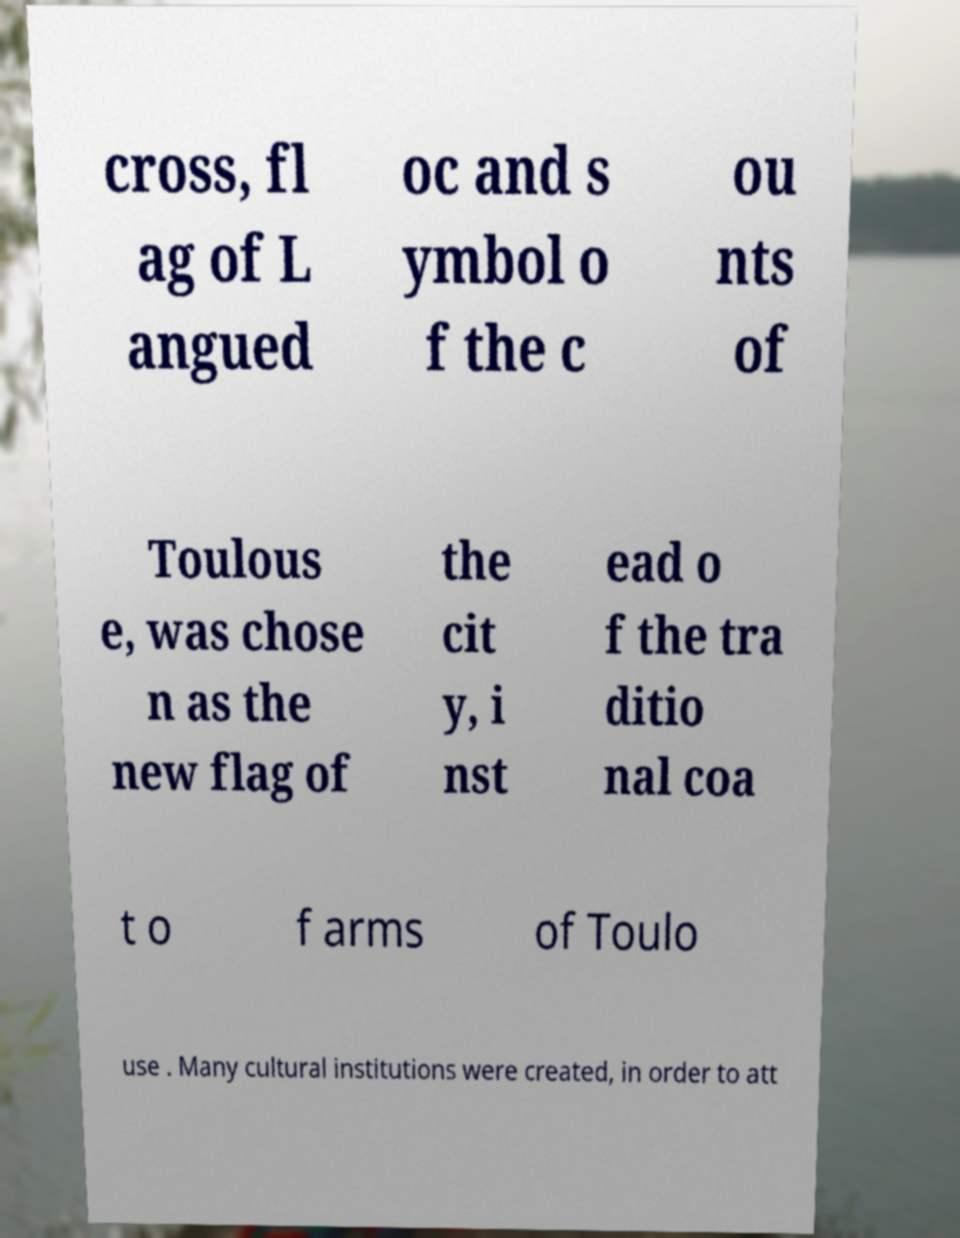What messages or text are displayed in this image? I need them in a readable, typed format. cross, fl ag of L angued oc and s ymbol o f the c ou nts of Toulous e, was chose n as the new flag of the cit y, i nst ead o f the tra ditio nal coa t o f arms of Toulo use . Many cultural institutions were created, in order to att 